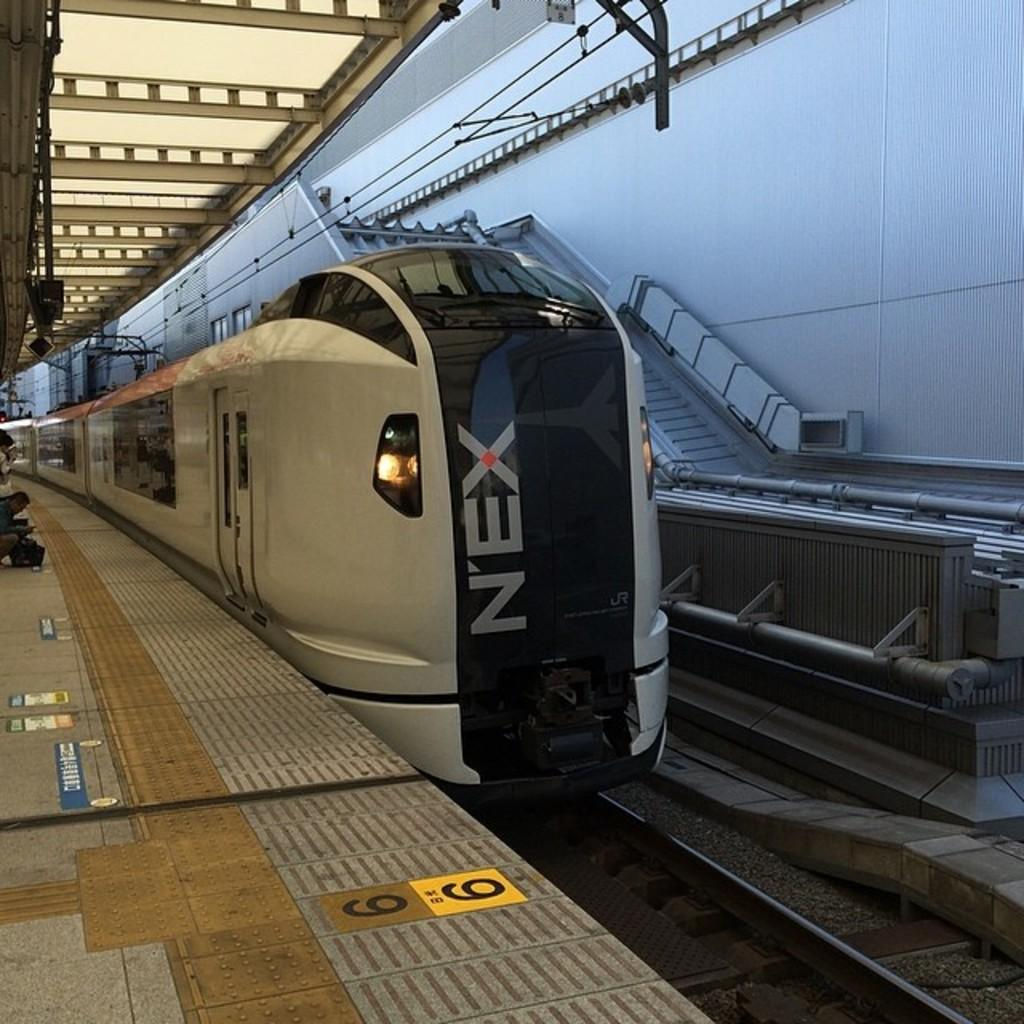What is the main subject of the image? The main subject of the image is a train. Where is the train located in the image? The train is on a railway track. What else can be seen in the image besides the train? There is a platform with people and steps visible in the image. What can be seen in the background of the image? There are rods visible in the background of the image. How many dolls are sitting on the knee of the person on the platform? There are no dolls or people mentioned in the image, so this question cannot be answered. 